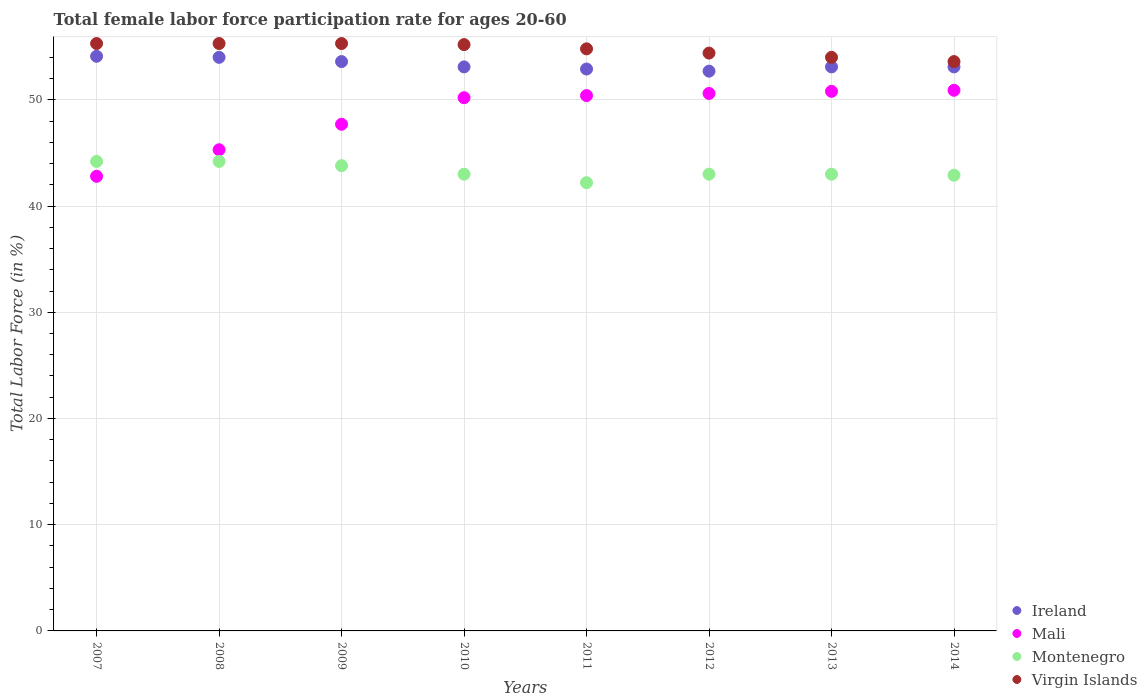Across all years, what is the maximum female labor force participation rate in Montenegro?
Ensure brevity in your answer.  44.2. Across all years, what is the minimum female labor force participation rate in Virgin Islands?
Provide a short and direct response. 53.6. What is the total female labor force participation rate in Montenegro in the graph?
Your answer should be very brief. 346.3. What is the difference between the female labor force participation rate in Montenegro in 2008 and that in 2014?
Your answer should be compact. 1.3. What is the difference between the female labor force participation rate in Ireland in 2011 and the female labor force participation rate in Mali in 2008?
Make the answer very short. 7.6. What is the average female labor force participation rate in Montenegro per year?
Keep it short and to the point. 43.29. In the year 2010, what is the difference between the female labor force participation rate in Montenegro and female labor force participation rate in Mali?
Provide a short and direct response. -7.2. In how many years, is the female labor force participation rate in Virgin Islands greater than 52 %?
Your response must be concise. 8. What is the ratio of the female labor force participation rate in Ireland in 2012 to that in 2013?
Your answer should be very brief. 0.99. What is the difference between the highest and the second highest female labor force participation rate in Montenegro?
Ensure brevity in your answer.  0. What is the difference between the highest and the lowest female labor force participation rate in Montenegro?
Your response must be concise. 2. In how many years, is the female labor force participation rate in Ireland greater than the average female labor force participation rate in Ireland taken over all years?
Your answer should be compact. 3. Does the female labor force participation rate in Montenegro monotonically increase over the years?
Give a very brief answer. No. What is the difference between two consecutive major ticks on the Y-axis?
Provide a succinct answer. 10. Does the graph contain any zero values?
Your answer should be very brief. No. Does the graph contain grids?
Keep it short and to the point. Yes. Where does the legend appear in the graph?
Your response must be concise. Bottom right. How are the legend labels stacked?
Provide a succinct answer. Vertical. What is the title of the graph?
Your response must be concise. Total female labor force participation rate for ages 20-60. What is the label or title of the X-axis?
Ensure brevity in your answer.  Years. What is the label or title of the Y-axis?
Ensure brevity in your answer.  Total Labor Force (in %). What is the Total Labor Force (in %) in Ireland in 2007?
Provide a short and direct response. 54.1. What is the Total Labor Force (in %) in Mali in 2007?
Provide a short and direct response. 42.8. What is the Total Labor Force (in %) of Montenegro in 2007?
Offer a terse response. 44.2. What is the Total Labor Force (in %) of Virgin Islands in 2007?
Give a very brief answer. 55.3. What is the Total Labor Force (in %) in Ireland in 2008?
Offer a terse response. 54. What is the Total Labor Force (in %) in Mali in 2008?
Your response must be concise. 45.3. What is the Total Labor Force (in %) in Montenegro in 2008?
Provide a succinct answer. 44.2. What is the Total Labor Force (in %) in Virgin Islands in 2008?
Offer a very short reply. 55.3. What is the Total Labor Force (in %) of Ireland in 2009?
Provide a succinct answer. 53.6. What is the Total Labor Force (in %) of Mali in 2009?
Your response must be concise. 47.7. What is the Total Labor Force (in %) in Montenegro in 2009?
Your answer should be compact. 43.8. What is the Total Labor Force (in %) in Virgin Islands in 2009?
Your answer should be compact. 55.3. What is the Total Labor Force (in %) of Ireland in 2010?
Provide a short and direct response. 53.1. What is the Total Labor Force (in %) of Mali in 2010?
Your answer should be very brief. 50.2. What is the Total Labor Force (in %) of Virgin Islands in 2010?
Keep it short and to the point. 55.2. What is the Total Labor Force (in %) in Ireland in 2011?
Keep it short and to the point. 52.9. What is the Total Labor Force (in %) of Mali in 2011?
Offer a very short reply. 50.4. What is the Total Labor Force (in %) in Montenegro in 2011?
Offer a terse response. 42.2. What is the Total Labor Force (in %) in Virgin Islands in 2011?
Offer a very short reply. 54.8. What is the Total Labor Force (in %) of Ireland in 2012?
Offer a terse response. 52.7. What is the Total Labor Force (in %) of Mali in 2012?
Your answer should be compact. 50.6. What is the Total Labor Force (in %) of Virgin Islands in 2012?
Provide a short and direct response. 54.4. What is the Total Labor Force (in %) of Ireland in 2013?
Provide a short and direct response. 53.1. What is the Total Labor Force (in %) of Mali in 2013?
Ensure brevity in your answer.  50.8. What is the Total Labor Force (in %) in Montenegro in 2013?
Offer a terse response. 43. What is the Total Labor Force (in %) in Ireland in 2014?
Your answer should be very brief. 53.1. What is the Total Labor Force (in %) of Mali in 2014?
Ensure brevity in your answer.  50.9. What is the Total Labor Force (in %) of Montenegro in 2014?
Your answer should be very brief. 42.9. What is the Total Labor Force (in %) in Virgin Islands in 2014?
Your answer should be very brief. 53.6. Across all years, what is the maximum Total Labor Force (in %) of Ireland?
Provide a succinct answer. 54.1. Across all years, what is the maximum Total Labor Force (in %) in Mali?
Your answer should be compact. 50.9. Across all years, what is the maximum Total Labor Force (in %) in Montenegro?
Make the answer very short. 44.2. Across all years, what is the maximum Total Labor Force (in %) in Virgin Islands?
Ensure brevity in your answer.  55.3. Across all years, what is the minimum Total Labor Force (in %) in Ireland?
Offer a very short reply. 52.7. Across all years, what is the minimum Total Labor Force (in %) of Mali?
Your answer should be very brief. 42.8. Across all years, what is the minimum Total Labor Force (in %) in Montenegro?
Your response must be concise. 42.2. Across all years, what is the minimum Total Labor Force (in %) in Virgin Islands?
Make the answer very short. 53.6. What is the total Total Labor Force (in %) of Ireland in the graph?
Provide a succinct answer. 426.6. What is the total Total Labor Force (in %) in Mali in the graph?
Your answer should be compact. 388.7. What is the total Total Labor Force (in %) in Montenegro in the graph?
Ensure brevity in your answer.  346.3. What is the total Total Labor Force (in %) of Virgin Islands in the graph?
Provide a short and direct response. 437.9. What is the difference between the Total Labor Force (in %) of Ireland in 2007 and that in 2008?
Provide a succinct answer. 0.1. What is the difference between the Total Labor Force (in %) of Mali in 2007 and that in 2008?
Your response must be concise. -2.5. What is the difference between the Total Labor Force (in %) of Montenegro in 2007 and that in 2008?
Provide a succinct answer. 0. What is the difference between the Total Labor Force (in %) in Ireland in 2007 and that in 2009?
Offer a very short reply. 0.5. What is the difference between the Total Labor Force (in %) of Mali in 2007 and that in 2009?
Keep it short and to the point. -4.9. What is the difference between the Total Labor Force (in %) in Ireland in 2007 and that in 2010?
Provide a succinct answer. 1. What is the difference between the Total Labor Force (in %) of Mali in 2007 and that in 2010?
Provide a succinct answer. -7.4. What is the difference between the Total Labor Force (in %) of Montenegro in 2007 and that in 2011?
Provide a short and direct response. 2. What is the difference between the Total Labor Force (in %) of Virgin Islands in 2007 and that in 2011?
Give a very brief answer. 0.5. What is the difference between the Total Labor Force (in %) in Mali in 2007 and that in 2012?
Offer a terse response. -7.8. What is the difference between the Total Labor Force (in %) in Montenegro in 2007 and that in 2012?
Provide a short and direct response. 1.2. What is the difference between the Total Labor Force (in %) in Ireland in 2007 and that in 2013?
Provide a short and direct response. 1. What is the difference between the Total Labor Force (in %) in Montenegro in 2007 and that in 2014?
Ensure brevity in your answer.  1.3. What is the difference between the Total Labor Force (in %) in Virgin Islands in 2007 and that in 2014?
Provide a succinct answer. 1.7. What is the difference between the Total Labor Force (in %) in Ireland in 2008 and that in 2009?
Offer a very short reply. 0.4. What is the difference between the Total Labor Force (in %) of Virgin Islands in 2008 and that in 2009?
Make the answer very short. 0. What is the difference between the Total Labor Force (in %) of Ireland in 2008 and that in 2010?
Give a very brief answer. 0.9. What is the difference between the Total Labor Force (in %) of Mali in 2008 and that in 2010?
Ensure brevity in your answer.  -4.9. What is the difference between the Total Labor Force (in %) in Montenegro in 2008 and that in 2010?
Offer a terse response. 1.2. What is the difference between the Total Labor Force (in %) in Montenegro in 2008 and that in 2011?
Ensure brevity in your answer.  2. What is the difference between the Total Labor Force (in %) of Virgin Islands in 2008 and that in 2011?
Give a very brief answer. 0.5. What is the difference between the Total Labor Force (in %) in Mali in 2008 and that in 2013?
Your answer should be very brief. -5.5. What is the difference between the Total Labor Force (in %) in Montenegro in 2008 and that in 2013?
Keep it short and to the point. 1.2. What is the difference between the Total Labor Force (in %) of Mali in 2008 and that in 2014?
Provide a succinct answer. -5.6. What is the difference between the Total Labor Force (in %) in Montenegro in 2008 and that in 2014?
Keep it short and to the point. 1.3. What is the difference between the Total Labor Force (in %) in Virgin Islands in 2008 and that in 2014?
Offer a very short reply. 1.7. What is the difference between the Total Labor Force (in %) in Ireland in 2009 and that in 2010?
Your response must be concise. 0.5. What is the difference between the Total Labor Force (in %) of Mali in 2009 and that in 2010?
Keep it short and to the point. -2.5. What is the difference between the Total Labor Force (in %) of Montenegro in 2009 and that in 2010?
Ensure brevity in your answer.  0.8. What is the difference between the Total Labor Force (in %) in Ireland in 2009 and that in 2011?
Make the answer very short. 0.7. What is the difference between the Total Labor Force (in %) of Mali in 2009 and that in 2012?
Offer a terse response. -2.9. What is the difference between the Total Labor Force (in %) of Ireland in 2009 and that in 2013?
Make the answer very short. 0.5. What is the difference between the Total Labor Force (in %) in Montenegro in 2009 and that in 2013?
Ensure brevity in your answer.  0.8. What is the difference between the Total Labor Force (in %) of Virgin Islands in 2009 and that in 2013?
Make the answer very short. 1.3. What is the difference between the Total Labor Force (in %) of Mali in 2009 and that in 2014?
Ensure brevity in your answer.  -3.2. What is the difference between the Total Labor Force (in %) in Mali in 2010 and that in 2011?
Your answer should be very brief. -0.2. What is the difference between the Total Labor Force (in %) of Montenegro in 2010 and that in 2011?
Provide a succinct answer. 0.8. What is the difference between the Total Labor Force (in %) of Virgin Islands in 2010 and that in 2011?
Provide a succinct answer. 0.4. What is the difference between the Total Labor Force (in %) in Ireland in 2010 and that in 2012?
Your answer should be very brief. 0.4. What is the difference between the Total Labor Force (in %) of Mali in 2010 and that in 2012?
Give a very brief answer. -0.4. What is the difference between the Total Labor Force (in %) of Montenegro in 2010 and that in 2012?
Offer a very short reply. 0. What is the difference between the Total Labor Force (in %) in Ireland in 2010 and that in 2013?
Offer a terse response. 0. What is the difference between the Total Labor Force (in %) in Mali in 2010 and that in 2013?
Provide a short and direct response. -0.6. What is the difference between the Total Labor Force (in %) in Montenegro in 2010 and that in 2013?
Offer a very short reply. 0. What is the difference between the Total Labor Force (in %) in Ireland in 2010 and that in 2014?
Make the answer very short. 0. What is the difference between the Total Labor Force (in %) of Montenegro in 2010 and that in 2014?
Provide a short and direct response. 0.1. What is the difference between the Total Labor Force (in %) of Ireland in 2011 and that in 2012?
Your answer should be very brief. 0.2. What is the difference between the Total Labor Force (in %) of Mali in 2011 and that in 2012?
Make the answer very short. -0.2. What is the difference between the Total Labor Force (in %) of Montenegro in 2011 and that in 2012?
Provide a succinct answer. -0.8. What is the difference between the Total Labor Force (in %) of Virgin Islands in 2011 and that in 2012?
Offer a very short reply. 0.4. What is the difference between the Total Labor Force (in %) in Ireland in 2011 and that in 2013?
Make the answer very short. -0.2. What is the difference between the Total Labor Force (in %) in Mali in 2011 and that in 2013?
Give a very brief answer. -0.4. What is the difference between the Total Labor Force (in %) of Mali in 2011 and that in 2014?
Offer a very short reply. -0.5. What is the difference between the Total Labor Force (in %) of Montenegro in 2011 and that in 2014?
Offer a very short reply. -0.7. What is the difference between the Total Labor Force (in %) of Ireland in 2012 and that in 2013?
Provide a succinct answer. -0.4. What is the difference between the Total Labor Force (in %) of Montenegro in 2012 and that in 2014?
Offer a terse response. 0.1. What is the difference between the Total Labor Force (in %) of Virgin Islands in 2012 and that in 2014?
Provide a succinct answer. 0.8. What is the difference between the Total Labor Force (in %) in Ireland in 2007 and the Total Labor Force (in %) in Virgin Islands in 2008?
Your response must be concise. -1.2. What is the difference between the Total Labor Force (in %) of Mali in 2007 and the Total Labor Force (in %) of Virgin Islands in 2008?
Make the answer very short. -12.5. What is the difference between the Total Labor Force (in %) in Ireland in 2007 and the Total Labor Force (in %) in Mali in 2009?
Offer a very short reply. 6.4. What is the difference between the Total Labor Force (in %) in Ireland in 2007 and the Total Labor Force (in %) in Montenegro in 2009?
Make the answer very short. 10.3. What is the difference between the Total Labor Force (in %) of Ireland in 2007 and the Total Labor Force (in %) of Virgin Islands in 2009?
Keep it short and to the point. -1.2. What is the difference between the Total Labor Force (in %) of Ireland in 2007 and the Total Labor Force (in %) of Mali in 2010?
Your answer should be very brief. 3.9. What is the difference between the Total Labor Force (in %) of Ireland in 2007 and the Total Labor Force (in %) of Montenegro in 2010?
Keep it short and to the point. 11.1. What is the difference between the Total Labor Force (in %) of Mali in 2007 and the Total Labor Force (in %) of Montenegro in 2010?
Your answer should be very brief. -0.2. What is the difference between the Total Labor Force (in %) of Montenegro in 2007 and the Total Labor Force (in %) of Virgin Islands in 2010?
Offer a very short reply. -11. What is the difference between the Total Labor Force (in %) of Ireland in 2007 and the Total Labor Force (in %) of Mali in 2011?
Ensure brevity in your answer.  3.7. What is the difference between the Total Labor Force (in %) in Mali in 2007 and the Total Labor Force (in %) in Virgin Islands in 2011?
Provide a succinct answer. -12. What is the difference between the Total Labor Force (in %) of Ireland in 2007 and the Total Labor Force (in %) of Virgin Islands in 2012?
Your answer should be compact. -0.3. What is the difference between the Total Labor Force (in %) of Ireland in 2007 and the Total Labor Force (in %) of Mali in 2013?
Ensure brevity in your answer.  3.3. What is the difference between the Total Labor Force (in %) in Ireland in 2007 and the Total Labor Force (in %) in Virgin Islands in 2013?
Provide a succinct answer. 0.1. What is the difference between the Total Labor Force (in %) of Ireland in 2007 and the Total Labor Force (in %) of Montenegro in 2014?
Your answer should be very brief. 11.2. What is the difference between the Total Labor Force (in %) of Montenegro in 2007 and the Total Labor Force (in %) of Virgin Islands in 2014?
Your answer should be very brief. -9.4. What is the difference between the Total Labor Force (in %) of Ireland in 2008 and the Total Labor Force (in %) of Mali in 2010?
Your response must be concise. 3.8. What is the difference between the Total Labor Force (in %) in Ireland in 2008 and the Total Labor Force (in %) in Montenegro in 2010?
Ensure brevity in your answer.  11. What is the difference between the Total Labor Force (in %) in Mali in 2008 and the Total Labor Force (in %) in Montenegro in 2010?
Your answer should be very brief. 2.3. What is the difference between the Total Labor Force (in %) in Montenegro in 2008 and the Total Labor Force (in %) in Virgin Islands in 2010?
Make the answer very short. -11. What is the difference between the Total Labor Force (in %) of Ireland in 2008 and the Total Labor Force (in %) of Montenegro in 2011?
Your answer should be very brief. 11.8. What is the difference between the Total Labor Force (in %) in Mali in 2008 and the Total Labor Force (in %) in Montenegro in 2011?
Give a very brief answer. 3.1. What is the difference between the Total Labor Force (in %) of Ireland in 2008 and the Total Labor Force (in %) of Virgin Islands in 2012?
Your response must be concise. -0.4. What is the difference between the Total Labor Force (in %) in Mali in 2008 and the Total Labor Force (in %) in Virgin Islands in 2012?
Offer a very short reply. -9.1. What is the difference between the Total Labor Force (in %) in Ireland in 2008 and the Total Labor Force (in %) in Mali in 2013?
Ensure brevity in your answer.  3.2. What is the difference between the Total Labor Force (in %) in Ireland in 2008 and the Total Labor Force (in %) in Virgin Islands in 2013?
Keep it short and to the point. 0. What is the difference between the Total Labor Force (in %) of Mali in 2008 and the Total Labor Force (in %) of Montenegro in 2013?
Provide a short and direct response. 2.3. What is the difference between the Total Labor Force (in %) of Ireland in 2008 and the Total Labor Force (in %) of Montenegro in 2014?
Your answer should be compact. 11.1. What is the difference between the Total Labor Force (in %) of Montenegro in 2008 and the Total Labor Force (in %) of Virgin Islands in 2014?
Your answer should be compact. -9.4. What is the difference between the Total Labor Force (in %) of Ireland in 2009 and the Total Labor Force (in %) of Mali in 2010?
Your response must be concise. 3.4. What is the difference between the Total Labor Force (in %) in Ireland in 2009 and the Total Labor Force (in %) in Montenegro in 2010?
Offer a very short reply. 10.6. What is the difference between the Total Labor Force (in %) in Mali in 2009 and the Total Labor Force (in %) in Montenegro in 2010?
Give a very brief answer. 4.7. What is the difference between the Total Labor Force (in %) of Ireland in 2009 and the Total Labor Force (in %) of Montenegro in 2011?
Your response must be concise. 11.4. What is the difference between the Total Labor Force (in %) of Ireland in 2009 and the Total Labor Force (in %) of Mali in 2012?
Your answer should be very brief. 3. What is the difference between the Total Labor Force (in %) of Ireland in 2009 and the Total Labor Force (in %) of Montenegro in 2012?
Give a very brief answer. 10.6. What is the difference between the Total Labor Force (in %) in Ireland in 2009 and the Total Labor Force (in %) in Virgin Islands in 2012?
Offer a terse response. -0.8. What is the difference between the Total Labor Force (in %) in Montenegro in 2009 and the Total Labor Force (in %) in Virgin Islands in 2012?
Your answer should be very brief. -10.6. What is the difference between the Total Labor Force (in %) in Ireland in 2009 and the Total Labor Force (in %) in Mali in 2013?
Provide a succinct answer. 2.8. What is the difference between the Total Labor Force (in %) in Ireland in 2009 and the Total Labor Force (in %) in Virgin Islands in 2013?
Ensure brevity in your answer.  -0.4. What is the difference between the Total Labor Force (in %) in Mali in 2009 and the Total Labor Force (in %) in Montenegro in 2013?
Your answer should be compact. 4.7. What is the difference between the Total Labor Force (in %) in Montenegro in 2009 and the Total Labor Force (in %) in Virgin Islands in 2013?
Your response must be concise. -10.2. What is the difference between the Total Labor Force (in %) in Ireland in 2009 and the Total Labor Force (in %) in Montenegro in 2014?
Make the answer very short. 10.7. What is the difference between the Total Labor Force (in %) of Ireland in 2009 and the Total Labor Force (in %) of Virgin Islands in 2014?
Offer a terse response. 0. What is the difference between the Total Labor Force (in %) in Mali in 2009 and the Total Labor Force (in %) in Montenegro in 2014?
Make the answer very short. 4.8. What is the difference between the Total Labor Force (in %) of Mali in 2009 and the Total Labor Force (in %) of Virgin Islands in 2014?
Make the answer very short. -5.9. What is the difference between the Total Labor Force (in %) in Montenegro in 2009 and the Total Labor Force (in %) in Virgin Islands in 2014?
Give a very brief answer. -9.8. What is the difference between the Total Labor Force (in %) of Ireland in 2010 and the Total Labor Force (in %) of Montenegro in 2011?
Offer a terse response. 10.9. What is the difference between the Total Labor Force (in %) of Mali in 2010 and the Total Labor Force (in %) of Montenegro in 2011?
Keep it short and to the point. 8. What is the difference between the Total Labor Force (in %) of Mali in 2010 and the Total Labor Force (in %) of Virgin Islands in 2011?
Keep it short and to the point. -4.6. What is the difference between the Total Labor Force (in %) of Montenegro in 2010 and the Total Labor Force (in %) of Virgin Islands in 2011?
Make the answer very short. -11.8. What is the difference between the Total Labor Force (in %) in Ireland in 2010 and the Total Labor Force (in %) in Montenegro in 2012?
Offer a very short reply. 10.1. What is the difference between the Total Labor Force (in %) in Ireland in 2010 and the Total Labor Force (in %) in Virgin Islands in 2012?
Provide a succinct answer. -1.3. What is the difference between the Total Labor Force (in %) in Mali in 2010 and the Total Labor Force (in %) in Montenegro in 2012?
Provide a short and direct response. 7.2. What is the difference between the Total Labor Force (in %) of Mali in 2010 and the Total Labor Force (in %) of Virgin Islands in 2012?
Make the answer very short. -4.2. What is the difference between the Total Labor Force (in %) in Ireland in 2010 and the Total Labor Force (in %) in Virgin Islands in 2013?
Offer a very short reply. -0.9. What is the difference between the Total Labor Force (in %) in Mali in 2010 and the Total Labor Force (in %) in Montenegro in 2013?
Make the answer very short. 7.2. What is the difference between the Total Labor Force (in %) of Mali in 2010 and the Total Labor Force (in %) of Virgin Islands in 2013?
Ensure brevity in your answer.  -3.8. What is the difference between the Total Labor Force (in %) of Ireland in 2010 and the Total Labor Force (in %) of Mali in 2014?
Give a very brief answer. 2.2. What is the difference between the Total Labor Force (in %) in Mali in 2010 and the Total Labor Force (in %) in Montenegro in 2014?
Your answer should be compact. 7.3. What is the difference between the Total Labor Force (in %) of Mali in 2010 and the Total Labor Force (in %) of Virgin Islands in 2014?
Your answer should be very brief. -3.4. What is the difference between the Total Labor Force (in %) in Montenegro in 2010 and the Total Labor Force (in %) in Virgin Islands in 2014?
Give a very brief answer. -10.6. What is the difference between the Total Labor Force (in %) of Ireland in 2011 and the Total Labor Force (in %) of Mali in 2012?
Your response must be concise. 2.3. What is the difference between the Total Labor Force (in %) of Ireland in 2011 and the Total Labor Force (in %) of Montenegro in 2012?
Provide a succinct answer. 9.9. What is the difference between the Total Labor Force (in %) of Ireland in 2011 and the Total Labor Force (in %) of Virgin Islands in 2012?
Keep it short and to the point. -1.5. What is the difference between the Total Labor Force (in %) of Mali in 2011 and the Total Labor Force (in %) of Montenegro in 2012?
Provide a short and direct response. 7.4. What is the difference between the Total Labor Force (in %) of Mali in 2011 and the Total Labor Force (in %) of Virgin Islands in 2012?
Your response must be concise. -4. What is the difference between the Total Labor Force (in %) in Montenegro in 2011 and the Total Labor Force (in %) in Virgin Islands in 2012?
Offer a terse response. -12.2. What is the difference between the Total Labor Force (in %) of Ireland in 2011 and the Total Labor Force (in %) of Mali in 2013?
Offer a terse response. 2.1. What is the difference between the Total Labor Force (in %) of Ireland in 2011 and the Total Labor Force (in %) of Montenegro in 2013?
Ensure brevity in your answer.  9.9. What is the difference between the Total Labor Force (in %) of Montenegro in 2011 and the Total Labor Force (in %) of Virgin Islands in 2013?
Give a very brief answer. -11.8. What is the difference between the Total Labor Force (in %) in Ireland in 2011 and the Total Labor Force (in %) in Montenegro in 2014?
Your response must be concise. 10. What is the difference between the Total Labor Force (in %) of Montenegro in 2011 and the Total Labor Force (in %) of Virgin Islands in 2014?
Give a very brief answer. -11.4. What is the difference between the Total Labor Force (in %) in Ireland in 2012 and the Total Labor Force (in %) in Mali in 2013?
Give a very brief answer. 1.9. What is the difference between the Total Labor Force (in %) of Mali in 2012 and the Total Labor Force (in %) of Montenegro in 2013?
Offer a terse response. 7.6. What is the difference between the Total Labor Force (in %) of Mali in 2012 and the Total Labor Force (in %) of Virgin Islands in 2013?
Offer a very short reply. -3.4. What is the difference between the Total Labor Force (in %) of Ireland in 2012 and the Total Labor Force (in %) of Virgin Islands in 2014?
Your response must be concise. -0.9. What is the difference between the Total Labor Force (in %) in Mali in 2012 and the Total Labor Force (in %) in Montenegro in 2014?
Offer a very short reply. 7.7. What is the difference between the Total Labor Force (in %) in Ireland in 2013 and the Total Labor Force (in %) in Montenegro in 2014?
Keep it short and to the point. 10.2. What is the difference between the Total Labor Force (in %) of Mali in 2013 and the Total Labor Force (in %) of Montenegro in 2014?
Provide a short and direct response. 7.9. What is the difference between the Total Labor Force (in %) in Montenegro in 2013 and the Total Labor Force (in %) in Virgin Islands in 2014?
Ensure brevity in your answer.  -10.6. What is the average Total Labor Force (in %) of Ireland per year?
Give a very brief answer. 53.33. What is the average Total Labor Force (in %) of Mali per year?
Provide a short and direct response. 48.59. What is the average Total Labor Force (in %) in Montenegro per year?
Offer a terse response. 43.29. What is the average Total Labor Force (in %) of Virgin Islands per year?
Make the answer very short. 54.74. In the year 2007, what is the difference between the Total Labor Force (in %) of Mali and Total Labor Force (in %) of Montenegro?
Ensure brevity in your answer.  -1.4. In the year 2007, what is the difference between the Total Labor Force (in %) of Montenegro and Total Labor Force (in %) of Virgin Islands?
Offer a terse response. -11.1. In the year 2008, what is the difference between the Total Labor Force (in %) in Ireland and Total Labor Force (in %) in Mali?
Make the answer very short. 8.7. In the year 2008, what is the difference between the Total Labor Force (in %) of Mali and Total Labor Force (in %) of Virgin Islands?
Your answer should be very brief. -10. In the year 2009, what is the difference between the Total Labor Force (in %) of Ireland and Total Labor Force (in %) of Virgin Islands?
Keep it short and to the point. -1.7. In the year 2009, what is the difference between the Total Labor Force (in %) in Mali and Total Labor Force (in %) in Montenegro?
Give a very brief answer. 3.9. In the year 2009, what is the difference between the Total Labor Force (in %) in Montenegro and Total Labor Force (in %) in Virgin Islands?
Give a very brief answer. -11.5. In the year 2010, what is the difference between the Total Labor Force (in %) in Ireland and Total Labor Force (in %) in Montenegro?
Keep it short and to the point. 10.1. In the year 2010, what is the difference between the Total Labor Force (in %) in Ireland and Total Labor Force (in %) in Virgin Islands?
Your answer should be very brief. -2.1. In the year 2011, what is the difference between the Total Labor Force (in %) in Montenegro and Total Labor Force (in %) in Virgin Islands?
Keep it short and to the point. -12.6. In the year 2012, what is the difference between the Total Labor Force (in %) of Ireland and Total Labor Force (in %) of Virgin Islands?
Provide a short and direct response. -1.7. In the year 2012, what is the difference between the Total Labor Force (in %) of Mali and Total Labor Force (in %) of Montenegro?
Make the answer very short. 7.6. In the year 2012, what is the difference between the Total Labor Force (in %) of Montenegro and Total Labor Force (in %) of Virgin Islands?
Offer a very short reply. -11.4. In the year 2013, what is the difference between the Total Labor Force (in %) in Ireland and Total Labor Force (in %) in Montenegro?
Ensure brevity in your answer.  10.1. In the year 2013, what is the difference between the Total Labor Force (in %) in Ireland and Total Labor Force (in %) in Virgin Islands?
Your answer should be compact. -0.9. In the year 2013, what is the difference between the Total Labor Force (in %) of Montenegro and Total Labor Force (in %) of Virgin Islands?
Provide a short and direct response. -11. In the year 2014, what is the difference between the Total Labor Force (in %) in Ireland and Total Labor Force (in %) in Virgin Islands?
Offer a very short reply. -0.5. In the year 2014, what is the difference between the Total Labor Force (in %) of Mali and Total Labor Force (in %) of Montenegro?
Keep it short and to the point. 8. What is the ratio of the Total Labor Force (in %) in Mali in 2007 to that in 2008?
Keep it short and to the point. 0.94. What is the ratio of the Total Labor Force (in %) in Montenegro in 2007 to that in 2008?
Your answer should be compact. 1. What is the ratio of the Total Labor Force (in %) in Virgin Islands in 2007 to that in 2008?
Provide a succinct answer. 1. What is the ratio of the Total Labor Force (in %) in Ireland in 2007 to that in 2009?
Provide a succinct answer. 1.01. What is the ratio of the Total Labor Force (in %) in Mali in 2007 to that in 2009?
Give a very brief answer. 0.9. What is the ratio of the Total Labor Force (in %) of Montenegro in 2007 to that in 2009?
Offer a very short reply. 1.01. What is the ratio of the Total Labor Force (in %) of Ireland in 2007 to that in 2010?
Provide a short and direct response. 1.02. What is the ratio of the Total Labor Force (in %) in Mali in 2007 to that in 2010?
Your response must be concise. 0.85. What is the ratio of the Total Labor Force (in %) in Montenegro in 2007 to that in 2010?
Your answer should be very brief. 1.03. What is the ratio of the Total Labor Force (in %) of Ireland in 2007 to that in 2011?
Your answer should be compact. 1.02. What is the ratio of the Total Labor Force (in %) in Mali in 2007 to that in 2011?
Make the answer very short. 0.85. What is the ratio of the Total Labor Force (in %) in Montenegro in 2007 to that in 2011?
Keep it short and to the point. 1.05. What is the ratio of the Total Labor Force (in %) of Virgin Islands in 2007 to that in 2011?
Your answer should be very brief. 1.01. What is the ratio of the Total Labor Force (in %) in Ireland in 2007 to that in 2012?
Keep it short and to the point. 1.03. What is the ratio of the Total Labor Force (in %) of Mali in 2007 to that in 2012?
Make the answer very short. 0.85. What is the ratio of the Total Labor Force (in %) of Montenegro in 2007 to that in 2012?
Make the answer very short. 1.03. What is the ratio of the Total Labor Force (in %) in Virgin Islands in 2007 to that in 2012?
Make the answer very short. 1.02. What is the ratio of the Total Labor Force (in %) of Ireland in 2007 to that in 2013?
Your answer should be compact. 1.02. What is the ratio of the Total Labor Force (in %) in Mali in 2007 to that in 2013?
Your answer should be very brief. 0.84. What is the ratio of the Total Labor Force (in %) in Montenegro in 2007 to that in 2013?
Your answer should be very brief. 1.03. What is the ratio of the Total Labor Force (in %) of Virgin Islands in 2007 to that in 2013?
Ensure brevity in your answer.  1.02. What is the ratio of the Total Labor Force (in %) in Ireland in 2007 to that in 2014?
Your answer should be compact. 1.02. What is the ratio of the Total Labor Force (in %) of Mali in 2007 to that in 2014?
Provide a succinct answer. 0.84. What is the ratio of the Total Labor Force (in %) of Montenegro in 2007 to that in 2014?
Your answer should be compact. 1.03. What is the ratio of the Total Labor Force (in %) in Virgin Islands in 2007 to that in 2014?
Offer a terse response. 1.03. What is the ratio of the Total Labor Force (in %) in Ireland in 2008 to that in 2009?
Provide a succinct answer. 1.01. What is the ratio of the Total Labor Force (in %) of Mali in 2008 to that in 2009?
Offer a very short reply. 0.95. What is the ratio of the Total Labor Force (in %) in Montenegro in 2008 to that in 2009?
Your answer should be compact. 1.01. What is the ratio of the Total Labor Force (in %) of Virgin Islands in 2008 to that in 2009?
Provide a short and direct response. 1. What is the ratio of the Total Labor Force (in %) of Ireland in 2008 to that in 2010?
Provide a short and direct response. 1.02. What is the ratio of the Total Labor Force (in %) in Mali in 2008 to that in 2010?
Your answer should be compact. 0.9. What is the ratio of the Total Labor Force (in %) of Montenegro in 2008 to that in 2010?
Your response must be concise. 1.03. What is the ratio of the Total Labor Force (in %) of Ireland in 2008 to that in 2011?
Your answer should be very brief. 1.02. What is the ratio of the Total Labor Force (in %) of Mali in 2008 to that in 2011?
Your response must be concise. 0.9. What is the ratio of the Total Labor Force (in %) of Montenegro in 2008 to that in 2011?
Give a very brief answer. 1.05. What is the ratio of the Total Labor Force (in %) of Virgin Islands in 2008 to that in 2011?
Ensure brevity in your answer.  1.01. What is the ratio of the Total Labor Force (in %) of Ireland in 2008 to that in 2012?
Provide a succinct answer. 1.02. What is the ratio of the Total Labor Force (in %) in Mali in 2008 to that in 2012?
Offer a very short reply. 0.9. What is the ratio of the Total Labor Force (in %) of Montenegro in 2008 to that in 2012?
Offer a terse response. 1.03. What is the ratio of the Total Labor Force (in %) of Virgin Islands in 2008 to that in 2012?
Ensure brevity in your answer.  1.02. What is the ratio of the Total Labor Force (in %) of Ireland in 2008 to that in 2013?
Keep it short and to the point. 1.02. What is the ratio of the Total Labor Force (in %) in Mali in 2008 to that in 2013?
Provide a succinct answer. 0.89. What is the ratio of the Total Labor Force (in %) of Montenegro in 2008 to that in 2013?
Your response must be concise. 1.03. What is the ratio of the Total Labor Force (in %) of Virgin Islands in 2008 to that in 2013?
Your answer should be very brief. 1.02. What is the ratio of the Total Labor Force (in %) of Ireland in 2008 to that in 2014?
Your answer should be very brief. 1.02. What is the ratio of the Total Labor Force (in %) in Mali in 2008 to that in 2014?
Provide a short and direct response. 0.89. What is the ratio of the Total Labor Force (in %) of Montenegro in 2008 to that in 2014?
Your answer should be very brief. 1.03. What is the ratio of the Total Labor Force (in %) in Virgin Islands in 2008 to that in 2014?
Offer a terse response. 1.03. What is the ratio of the Total Labor Force (in %) in Ireland in 2009 to that in 2010?
Provide a short and direct response. 1.01. What is the ratio of the Total Labor Force (in %) of Mali in 2009 to that in 2010?
Offer a terse response. 0.95. What is the ratio of the Total Labor Force (in %) in Montenegro in 2009 to that in 2010?
Your answer should be very brief. 1.02. What is the ratio of the Total Labor Force (in %) of Ireland in 2009 to that in 2011?
Your answer should be very brief. 1.01. What is the ratio of the Total Labor Force (in %) in Mali in 2009 to that in 2011?
Keep it short and to the point. 0.95. What is the ratio of the Total Labor Force (in %) in Montenegro in 2009 to that in 2011?
Your answer should be very brief. 1.04. What is the ratio of the Total Labor Force (in %) of Virgin Islands in 2009 to that in 2011?
Provide a succinct answer. 1.01. What is the ratio of the Total Labor Force (in %) in Ireland in 2009 to that in 2012?
Ensure brevity in your answer.  1.02. What is the ratio of the Total Labor Force (in %) of Mali in 2009 to that in 2012?
Give a very brief answer. 0.94. What is the ratio of the Total Labor Force (in %) in Montenegro in 2009 to that in 2012?
Your answer should be compact. 1.02. What is the ratio of the Total Labor Force (in %) in Virgin Islands in 2009 to that in 2012?
Your response must be concise. 1.02. What is the ratio of the Total Labor Force (in %) of Ireland in 2009 to that in 2013?
Your response must be concise. 1.01. What is the ratio of the Total Labor Force (in %) of Mali in 2009 to that in 2013?
Ensure brevity in your answer.  0.94. What is the ratio of the Total Labor Force (in %) of Montenegro in 2009 to that in 2013?
Your answer should be very brief. 1.02. What is the ratio of the Total Labor Force (in %) in Virgin Islands in 2009 to that in 2013?
Your response must be concise. 1.02. What is the ratio of the Total Labor Force (in %) in Ireland in 2009 to that in 2014?
Provide a short and direct response. 1.01. What is the ratio of the Total Labor Force (in %) of Mali in 2009 to that in 2014?
Make the answer very short. 0.94. What is the ratio of the Total Labor Force (in %) in Montenegro in 2009 to that in 2014?
Your answer should be compact. 1.02. What is the ratio of the Total Labor Force (in %) in Virgin Islands in 2009 to that in 2014?
Provide a succinct answer. 1.03. What is the ratio of the Total Labor Force (in %) in Ireland in 2010 to that in 2011?
Provide a short and direct response. 1. What is the ratio of the Total Labor Force (in %) in Virgin Islands in 2010 to that in 2011?
Provide a short and direct response. 1.01. What is the ratio of the Total Labor Force (in %) in Ireland in 2010 to that in 2012?
Offer a terse response. 1.01. What is the ratio of the Total Labor Force (in %) of Montenegro in 2010 to that in 2012?
Offer a terse response. 1. What is the ratio of the Total Labor Force (in %) of Virgin Islands in 2010 to that in 2012?
Your response must be concise. 1.01. What is the ratio of the Total Labor Force (in %) in Ireland in 2010 to that in 2013?
Keep it short and to the point. 1. What is the ratio of the Total Labor Force (in %) of Mali in 2010 to that in 2013?
Your answer should be compact. 0.99. What is the ratio of the Total Labor Force (in %) of Montenegro in 2010 to that in 2013?
Offer a terse response. 1. What is the ratio of the Total Labor Force (in %) in Virgin Islands in 2010 to that in 2013?
Provide a short and direct response. 1.02. What is the ratio of the Total Labor Force (in %) in Mali in 2010 to that in 2014?
Give a very brief answer. 0.99. What is the ratio of the Total Labor Force (in %) in Montenegro in 2010 to that in 2014?
Provide a succinct answer. 1. What is the ratio of the Total Labor Force (in %) of Virgin Islands in 2010 to that in 2014?
Provide a short and direct response. 1.03. What is the ratio of the Total Labor Force (in %) of Ireland in 2011 to that in 2012?
Your answer should be compact. 1. What is the ratio of the Total Labor Force (in %) of Montenegro in 2011 to that in 2012?
Make the answer very short. 0.98. What is the ratio of the Total Labor Force (in %) of Virgin Islands in 2011 to that in 2012?
Provide a short and direct response. 1.01. What is the ratio of the Total Labor Force (in %) of Ireland in 2011 to that in 2013?
Your response must be concise. 1. What is the ratio of the Total Labor Force (in %) in Mali in 2011 to that in 2013?
Your response must be concise. 0.99. What is the ratio of the Total Labor Force (in %) of Montenegro in 2011 to that in 2013?
Provide a short and direct response. 0.98. What is the ratio of the Total Labor Force (in %) in Virgin Islands in 2011 to that in 2013?
Provide a short and direct response. 1.01. What is the ratio of the Total Labor Force (in %) in Mali in 2011 to that in 2014?
Provide a short and direct response. 0.99. What is the ratio of the Total Labor Force (in %) in Montenegro in 2011 to that in 2014?
Offer a very short reply. 0.98. What is the ratio of the Total Labor Force (in %) of Virgin Islands in 2011 to that in 2014?
Provide a short and direct response. 1.02. What is the ratio of the Total Labor Force (in %) of Montenegro in 2012 to that in 2013?
Keep it short and to the point. 1. What is the ratio of the Total Labor Force (in %) of Virgin Islands in 2012 to that in 2013?
Offer a terse response. 1.01. What is the ratio of the Total Labor Force (in %) in Ireland in 2012 to that in 2014?
Offer a very short reply. 0.99. What is the ratio of the Total Labor Force (in %) of Mali in 2012 to that in 2014?
Your response must be concise. 0.99. What is the ratio of the Total Labor Force (in %) of Montenegro in 2012 to that in 2014?
Give a very brief answer. 1. What is the ratio of the Total Labor Force (in %) of Virgin Islands in 2012 to that in 2014?
Offer a terse response. 1.01. What is the ratio of the Total Labor Force (in %) in Mali in 2013 to that in 2014?
Your answer should be very brief. 1. What is the ratio of the Total Labor Force (in %) of Virgin Islands in 2013 to that in 2014?
Your answer should be very brief. 1.01. What is the difference between the highest and the second highest Total Labor Force (in %) in Ireland?
Your answer should be compact. 0.1. What is the difference between the highest and the second highest Total Labor Force (in %) of Mali?
Give a very brief answer. 0.1. What is the difference between the highest and the second highest Total Labor Force (in %) of Montenegro?
Give a very brief answer. 0. What is the difference between the highest and the second highest Total Labor Force (in %) of Virgin Islands?
Keep it short and to the point. 0. What is the difference between the highest and the lowest Total Labor Force (in %) in Montenegro?
Make the answer very short. 2. What is the difference between the highest and the lowest Total Labor Force (in %) of Virgin Islands?
Ensure brevity in your answer.  1.7. 